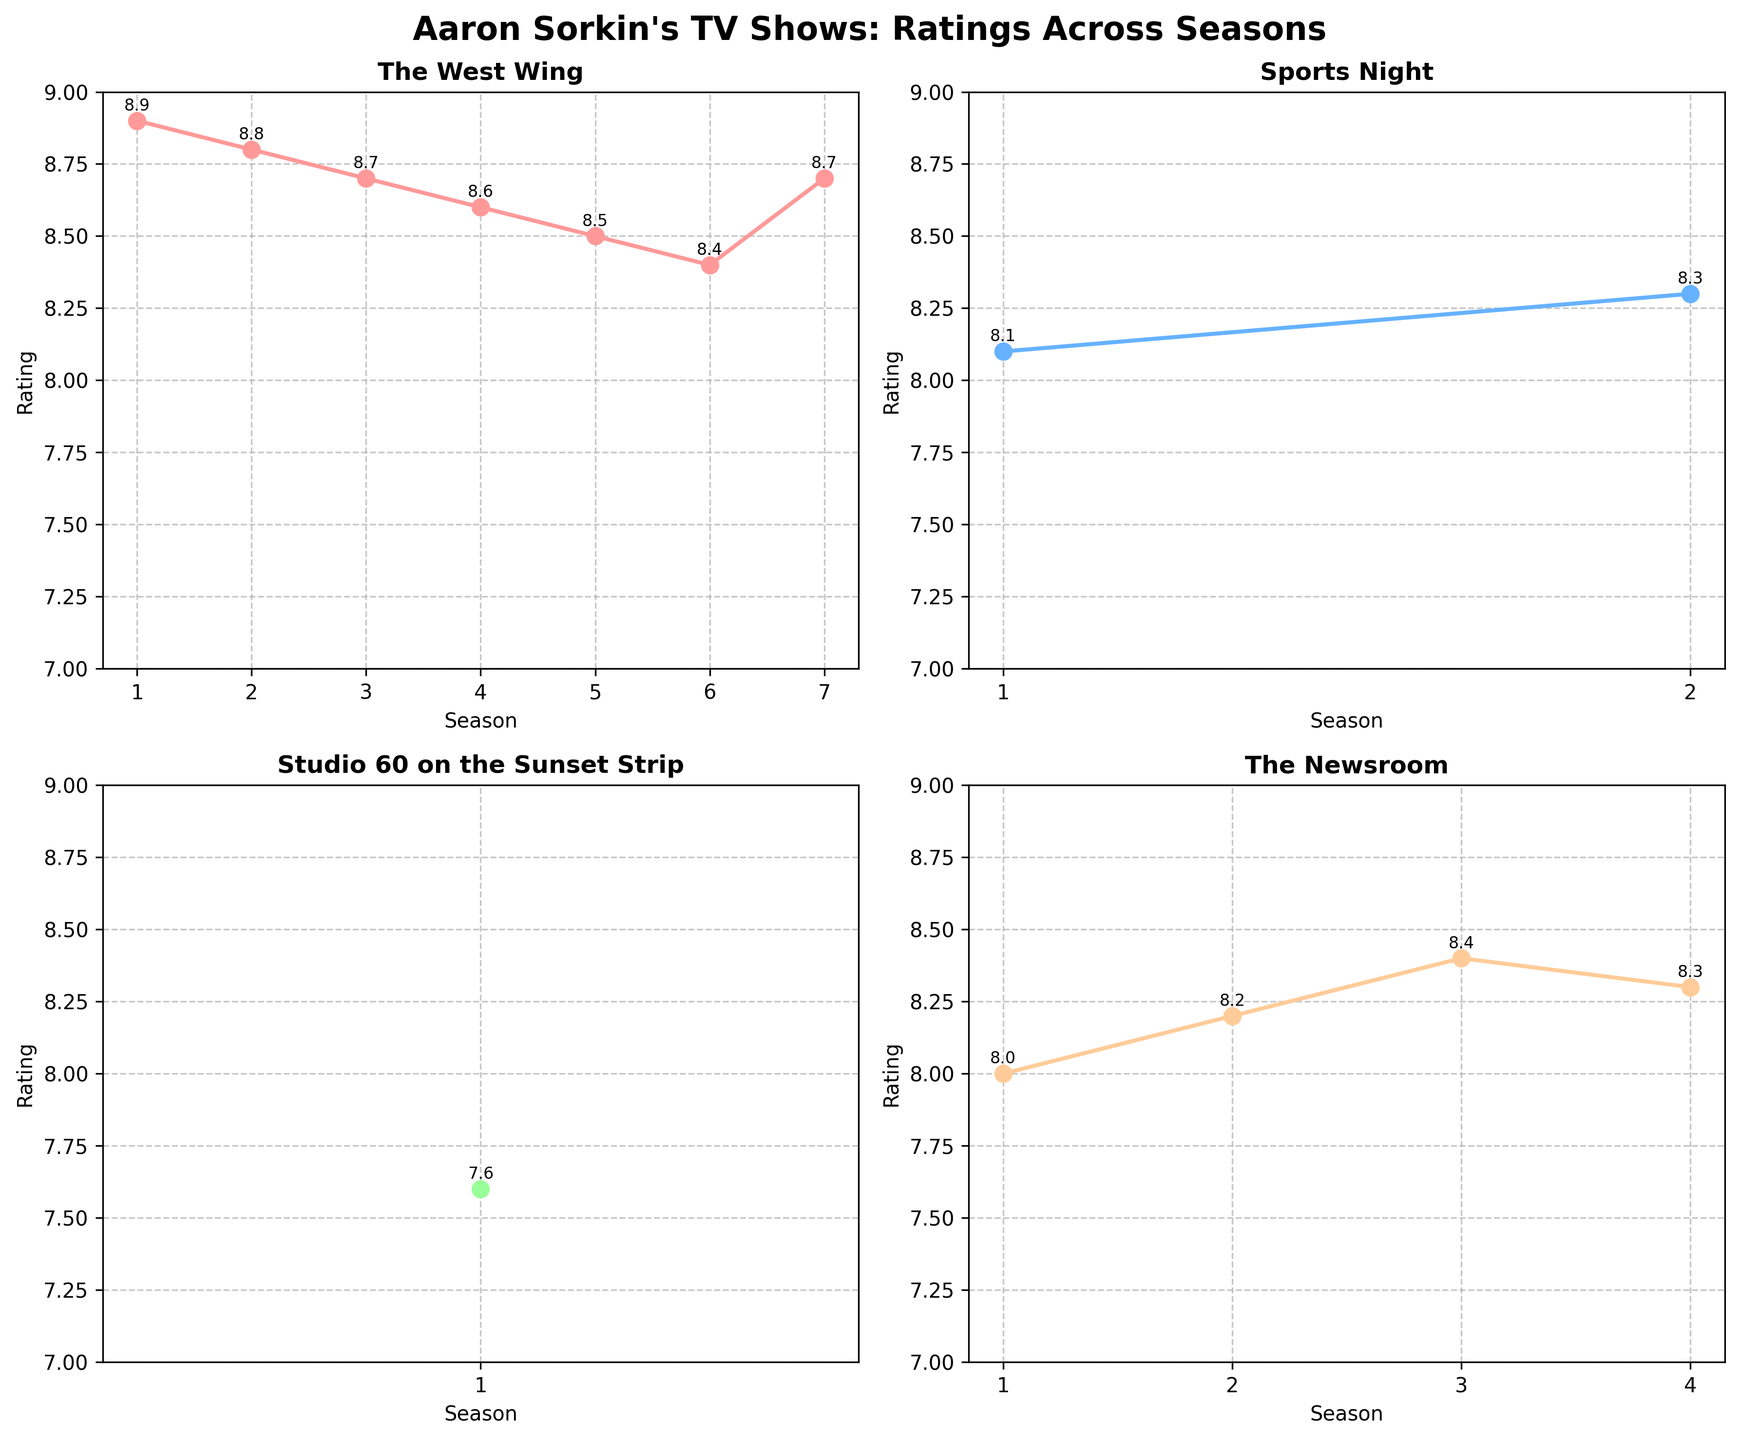what are the y-axis labels for each subplot? Each subplot's y-axis labels reflect the ratings out of 10.
Answer: Ratings What is the color of the plot line for "Studio 60 on the Sunset Strip"? In the subplot for "Studio 60 on the Sunset Strip," the color of the plot line is light orange.
Answer: Light Orange What season has the highest rating in "The West Wing"? The line plot for "The West Wing" shows the ratings for each season. The point with the highest rating is at Season 1 with a rating of 8.9.
Answer: Season 1 How does "The Newsroom"'s rating change between Season 1 and Season 2? In the subplot for "The Newsroom," the rating increases from Season 1 (8.0) to Season 2 (8.2).
Answer: It increases In which season did ratings for "Sports Night" peak? In the subplot for "Sports Night," the highest rating is in Season 2 with a rating of 8.3.
Answer: Season 2 how many seasons of "Sports Night" are shown in the figure? The subplot for "Sports Night" shows ratings for Seasons 1 and 2 only.
Answer: 2 seasons Calculate the average rating for "The West Wing" across all seasons shown. Adding all the ratings for "The West Wing" together (8.9 + 8.8 + 8.7 + 8.6 + 8.5 + 8.4 + 8.7) and dividing by the number of seasons (7) gives us the average: (60.6 / 7) ≈ 8.66.
Answer: 8.66 compare the ratings of Season 1 for all the TV shows. Which show had the lowest rating in its first season? From the subplots, we see the Season 1 ratings as follows: "The West Wing" - 8.9, "Sports Night" - 8.1, "Studio 60 on the Sunset Strip" - 7.6, "The Newsroom" - 8.0. The lowest rating in Season 1 is for "Studio 60 on the Sunset Strip" at 7.6.
Answer: "Studio 60 on the Sunset Strip" Examine the overall trend for "The West Wing"'s ratings from Season 1 to Season 7. Describe it. Viewing the subplot for "The West Wing," the ratings show a slight, gradual decline from Season 1 (8.9) to Season 6 (8.4), before rising again in Season 7 (8.7).
Answer: Gradual decline, then rise 